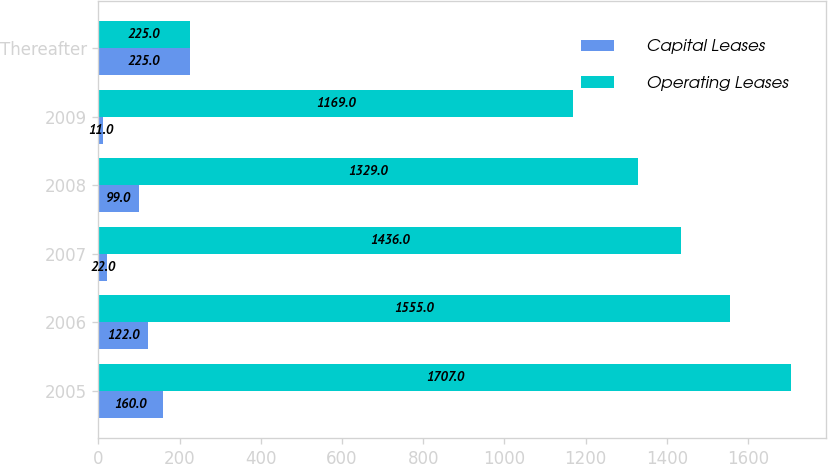Convert chart to OTSL. <chart><loc_0><loc_0><loc_500><loc_500><stacked_bar_chart><ecel><fcel>2005<fcel>2006<fcel>2007<fcel>2008<fcel>2009<fcel>Thereafter<nl><fcel>Capital Leases<fcel>160<fcel>122<fcel>22<fcel>99<fcel>11<fcel>225<nl><fcel>Operating Leases<fcel>1707<fcel>1555<fcel>1436<fcel>1329<fcel>1169<fcel>225<nl></chart> 